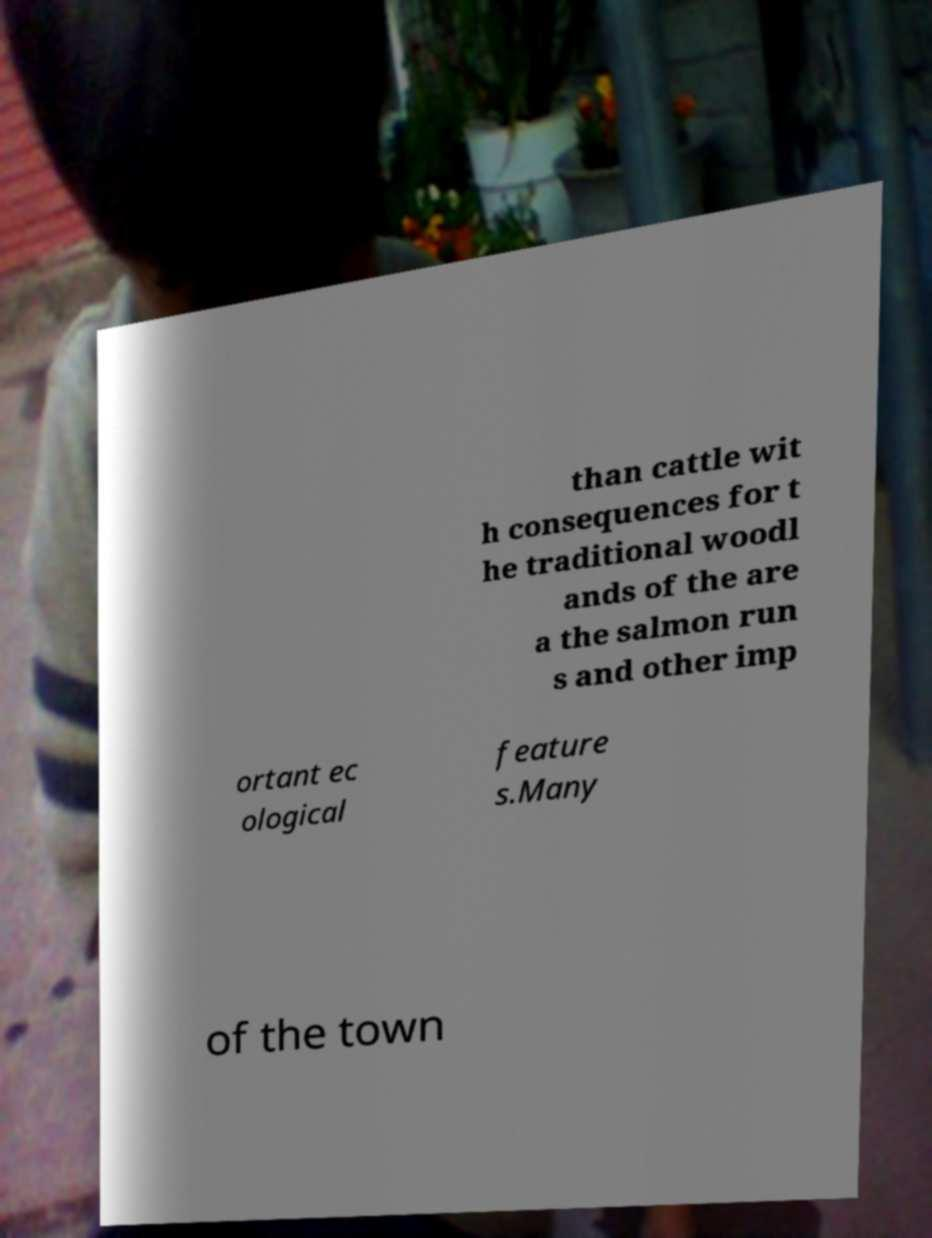What messages or text are displayed in this image? I need them in a readable, typed format. than cattle wit h consequences for t he traditional woodl ands of the are a the salmon run s and other imp ortant ec ological feature s.Many of the town 